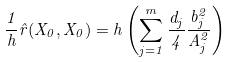Convert formula to latex. <formula><loc_0><loc_0><loc_500><loc_500>\frac { 1 } { h } \hat { r } ( X _ { 0 } , X _ { 0 } ) = h \left ( \sum _ { j = 1 } ^ { m } \frac { d _ { j } } { 4 } \frac { b _ { j } ^ { 2 } } { A _ { j } ^ { 2 } } \right )</formula> 